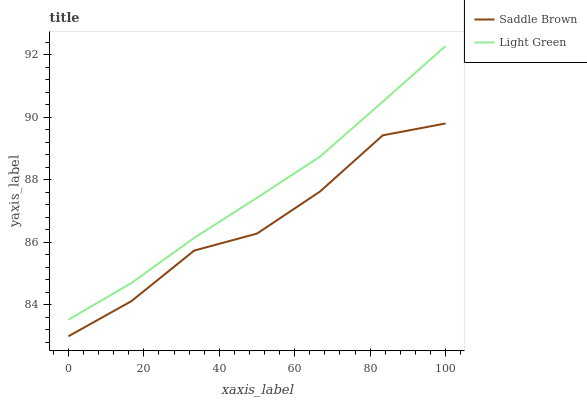Does Light Green have the minimum area under the curve?
Answer yes or no. No. Is Light Green the roughest?
Answer yes or no. No. Does Light Green have the lowest value?
Answer yes or no. No. Is Saddle Brown less than Light Green?
Answer yes or no. Yes. Is Light Green greater than Saddle Brown?
Answer yes or no. Yes. Does Saddle Brown intersect Light Green?
Answer yes or no. No. 